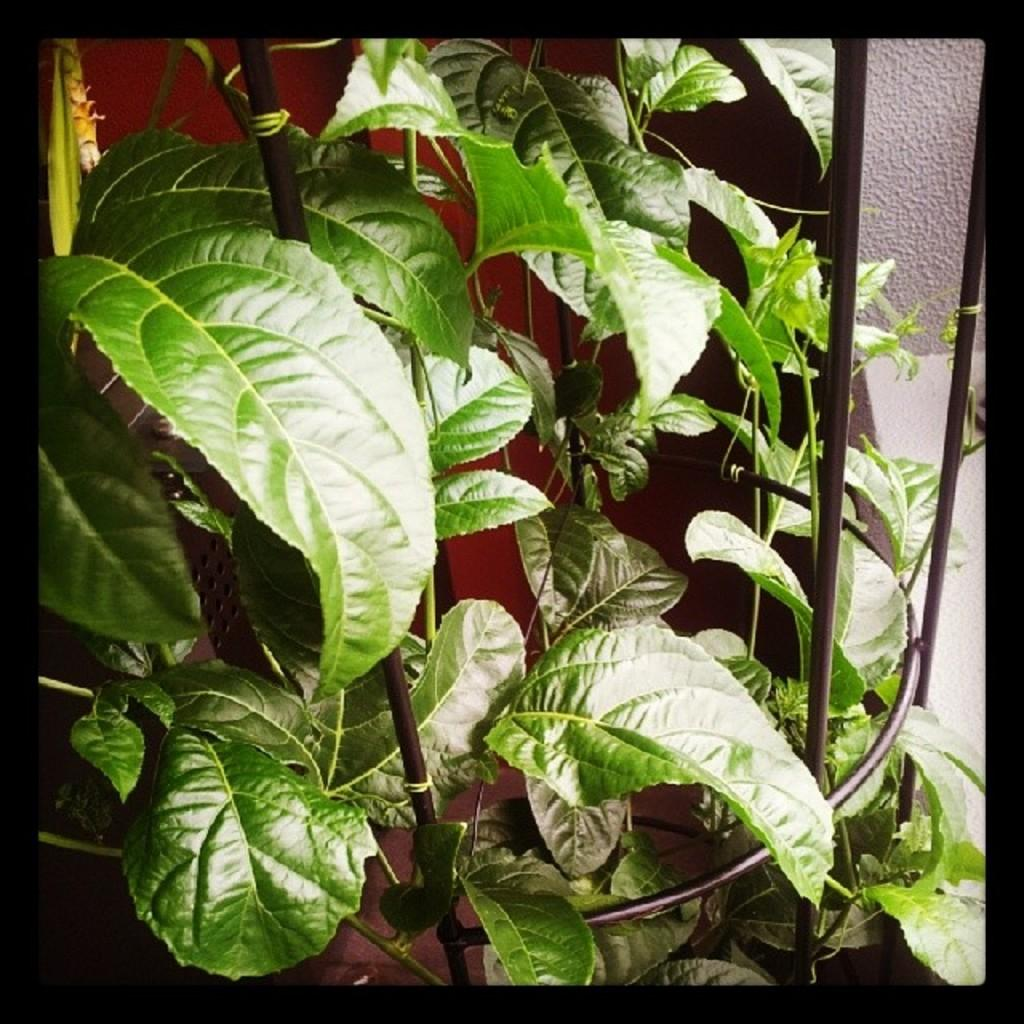What type of living organism can be seen in the image? There is a plant in the image. What is in front of the plant in the image? There is a railing in front of the plant. What can be seen in the background of the image? There is a wall in the background of the image. What type of songs can be heard coming from the plant in the image? There is no indication in the image that the plant is capable of producing or playing songs, as plants do not have the ability to create music. 